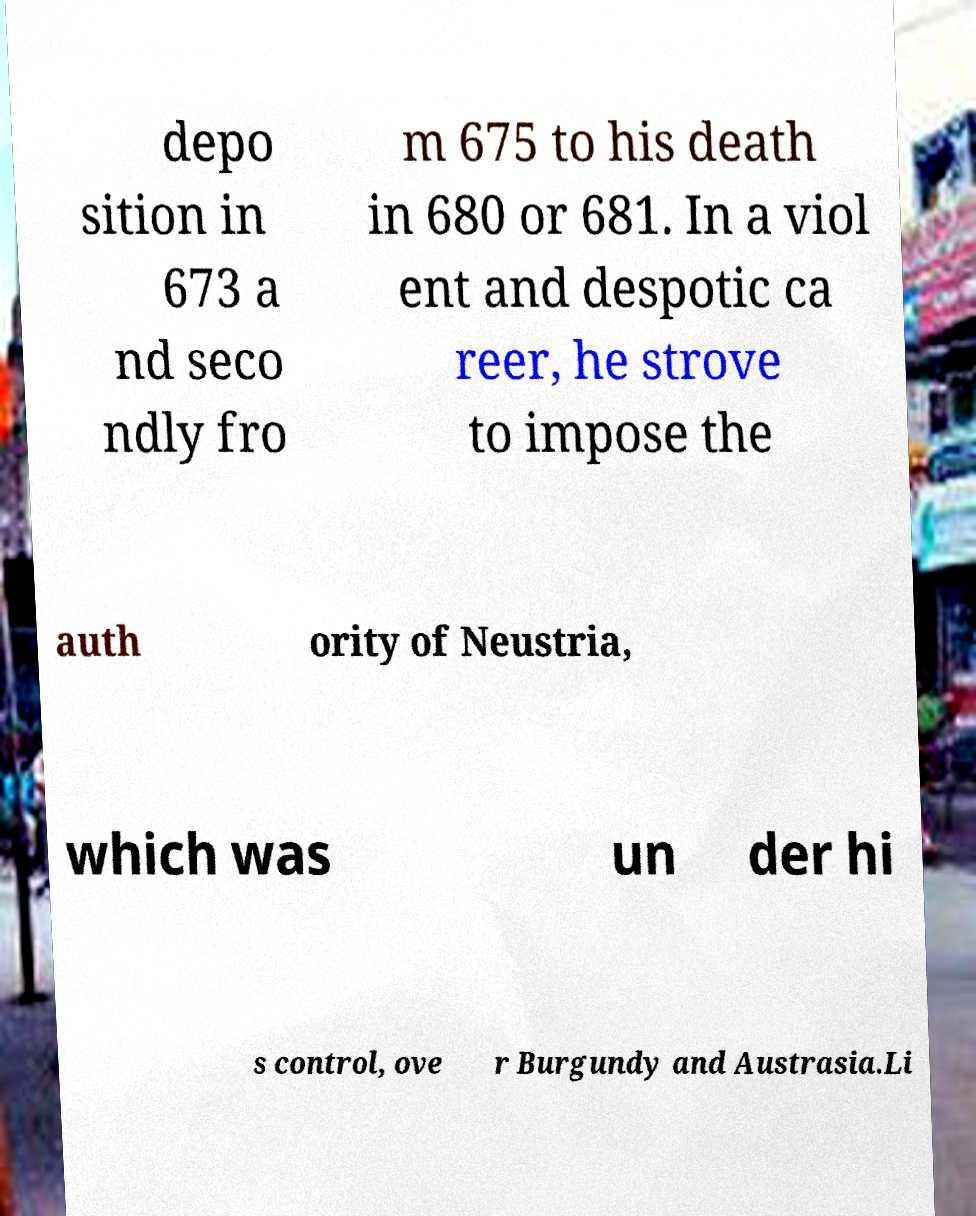Could you extract and type out the text from this image? depo sition in 673 a nd seco ndly fro m 675 to his death in 680 or 681. In a viol ent and despotic ca reer, he strove to impose the auth ority of Neustria, which was un der hi s control, ove r Burgundy and Austrasia.Li 